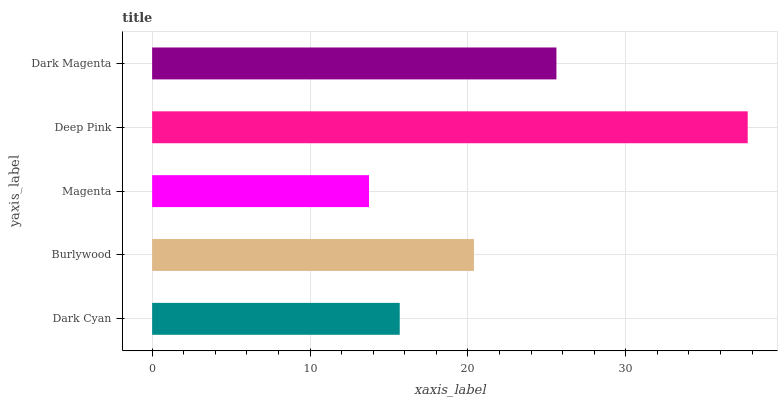Is Magenta the minimum?
Answer yes or no. Yes. Is Deep Pink the maximum?
Answer yes or no. Yes. Is Burlywood the minimum?
Answer yes or no. No. Is Burlywood the maximum?
Answer yes or no. No. Is Burlywood greater than Dark Cyan?
Answer yes or no. Yes. Is Dark Cyan less than Burlywood?
Answer yes or no. Yes. Is Dark Cyan greater than Burlywood?
Answer yes or no. No. Is Burlywood less than Dark Cyan?
Answer yes or no. No. Is Burlywood the high median?
Answer yes or no. Yes. Is Burlywood the low median?
Answer yes or no. Yes. Is Magenta the high median?
Answer yes or no. No. Is Magenta the low median?
Answer yes or no. No. 